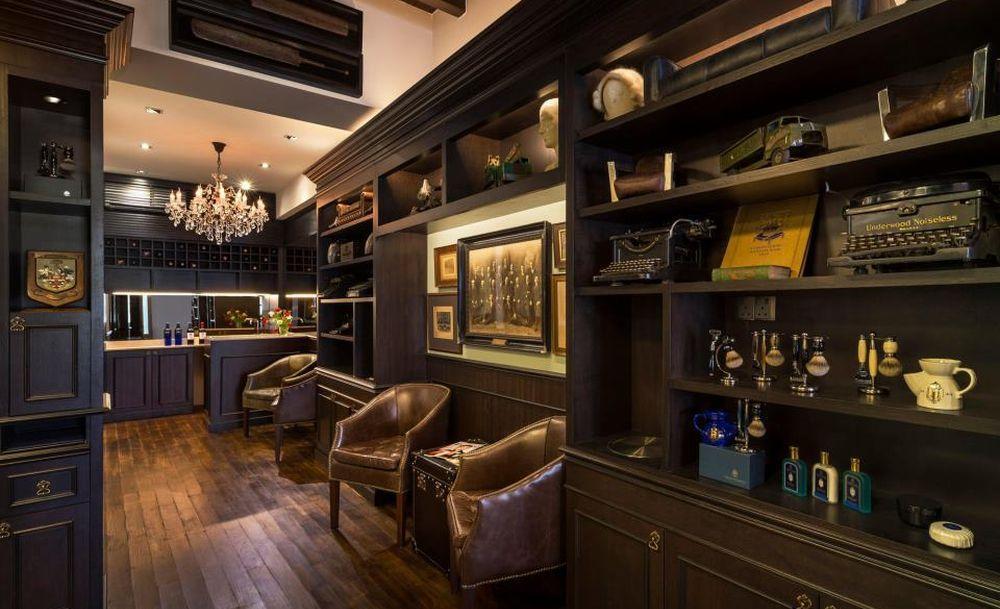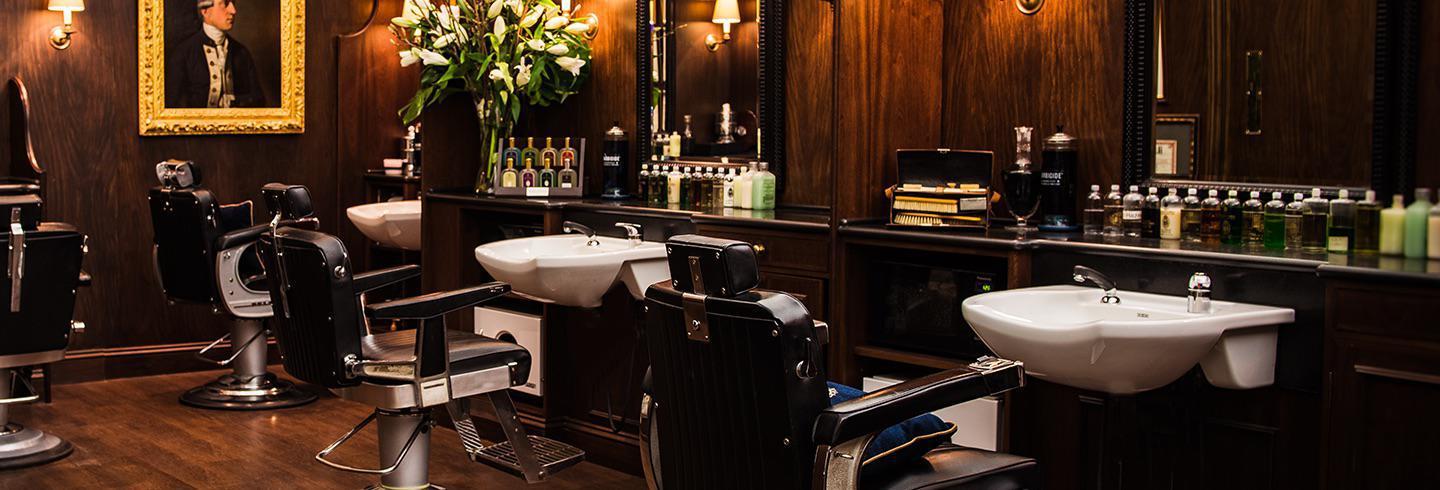The first image is the image on the left, the second image is the image on the right. Evaluate the accuracy of this statement regarding the images: "There are men in black vests working on a customer in a barber chair.". Is it true? Answer yes or no. No. The first image is the image on the left, the second image is the image on the right. For the images displayed, is the sentence "One image features the barbershop storefront, and they have the same name." factually correct? Answer yes or no. No. 